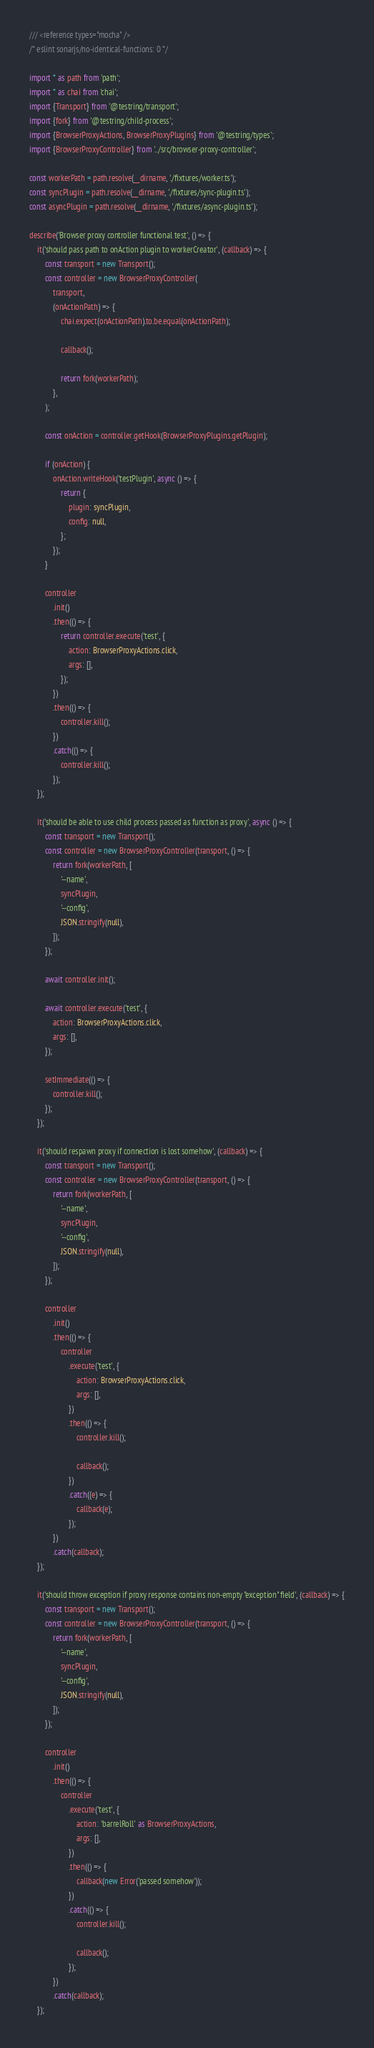Convert code to text. <code><loc_0><loc_0><loc_500><loc_500><_TypeScript_>/// <reference types="mocha" />
/* eslint sonarjs/no-identical-functions: 0 */

import * as path from 'path';
import * as chai from 'chai';
import {Transport} from '@testring/transport';
import {fork} from '@testring/child-process';
import {BrowserProxyActions, BrowserProxyPlugins} from '@testring/types';
import {BrowserProxyController} from '../src/browser-proxy-controller';

const workerPath = path.resolve(__dirname, './fixtures/worker.ts');
const syncPlugin = path.resolve(__dirname, './fixtures/sync-plugin.ts');
const asyncPlugin = path.resolve(__dirname, './fixtures/async-plugin.ts');

describe('Browser proxy controller functional test', () => {
    it('should pass path to onAction plugin to workerCreator', (callback) => {
        const transport = new Transport();
        const controller = new BrowserProxyController(
            transport,
            (onActionPath) => {
                chai.expect(onActionPath).to.be.equal(onActionPath);

                callback();

                return fork(workerPath);
            },
        );

        const onAction = controller.getHook(BrowserProxyPlugins.getPlugin);

        if (onAction) {
            onAction.writeHook('testPlugin', async () => {
                return {
                    plugin: syncPlugin,
                    config: null,
                };
            });
        }

        controller
            .init()
            .then(() => {
                return controller.execute('test', {
                    action: BrowserProxyActions.click,
                    args: [],
                });
            })
            .then(() => {
                controller.kill();
            })
            .catch(() => {
                controller.kill();
            });
    });

    it('should be able to use child process passed as function as proxy', async () => {
        const transport = new Transport();
        const controller = new BrowserProxyController(transport, () => {
            return fork(workerPath, [
                '--name',
                syncPlugin,
                '--config',
                JSON.stringify(null),
            ]);
        });

        await controller.init();

        await controller.execute('test', {
            action: BrowserProxyActions.click,
            args: [],
        });

        setImmediate(() => {
            controller.kill();
        });
    });

    it('should respawn proxy if connection is lost somehow', (callback) => {
        const transport = new Transport();
        const controller = new BrowserProxyController(transport, () => {
            return fork(workerPath, [
                '--name',
                syncPlugin,
                '--config',
                JSON.stringify(null),
            ]);
        });

        controller
            .init()
            .then(() => {
                controller
                    .execute('test', {
                        action: BrowserProxyActions.click,
                        args: [],
                    })
                    .then(() => {
                        controller.kill();

                        callback();
                    })
                    .catch((e) => {
                        callback(e);
                    });
            })
            .catch(callback);
    });

    it('should throw exception if proxy response contains non-empty "exception" field', (callback) => {
        const transport = new Transport();
        const controller = new BrowserProxyController(transport, () => {
            return fork(workerPath, [
                '--name',
                syncPlugin,
                '--config',
                JSON.stringify(null),
            ]);
        });

        controller
            .init()
            .then(() => {
                controller
                    .execute('test', {
                        action: 'barrelRoll' as BrowserProxyActions,
                        args: [],
                    })
                    .then(() => {
                        callback(new Error('passed somehow'));
                    })
                    .catch(() => {
                        controller.kill();

                        callback();
                    });
            })
            .catch(callback);
    });
</code> 